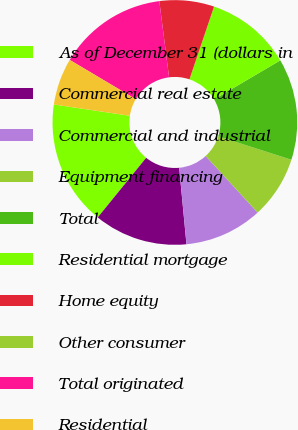Convert chart to OTSL. <chart><loc_0><loc_0><loc_500><loc_500><pie_chart><fcel>As of December 31 (dollars in<fcel>Commercial real estate<fcel>Commercial and industrial<fcel>Equipment financing<fcel>Total<fcel>Residential mortgage<fcel>Home equity<fcel>Other consumer<fcel>Total originated<fcel>Residential<nl><fcel>16.49%<fcel>12.37%<fcel>10.31%<fcel>8.25%<fcel>13.4%<fcel>11.34%<fcel>7.22%<fcel>0.0%<fcel>14.43%<fcel>6.19%<nl></chart> 